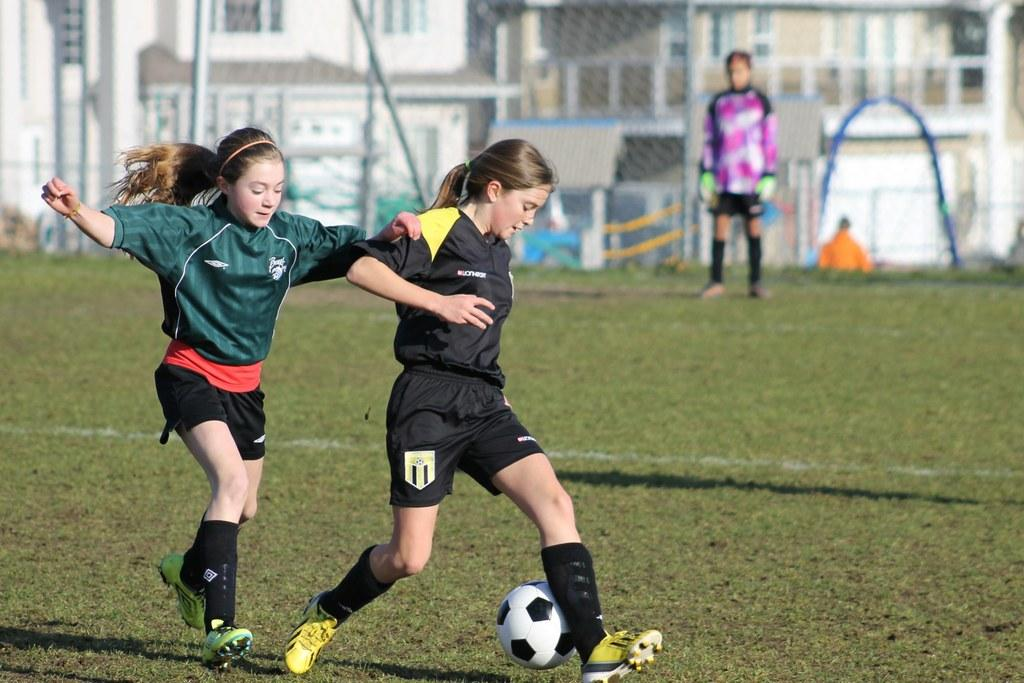How many people are in the image? There are two girls in the image. What activity are the girls engaged in? The girls are playing football. What can be seen in the background of the image? There is a metal grill fence in the image. Can you describe the positions of the players in the image? There is a goalkeeper on the right side of the image. What type of stew can be seen simmering in the background of the image? There is no stew present in the image; it features two girls playing football with a metal grill fence and a goalkeeper in the background. Can you hear the bells ringing in the image? There is no mention of bells or any sound in the image, so it is not possible to determine if they can be heard. 